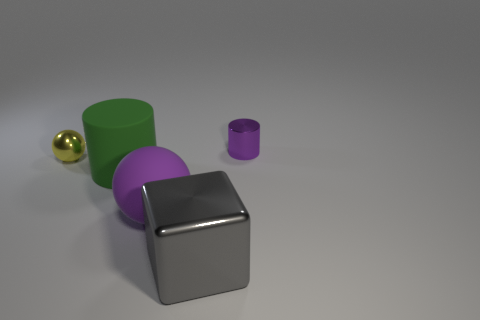What number of tiny metal cylinders have the same color as the matte ball?
Your response must be concise. 1. There is a object that is the same color as the large rubber ball; what size is it?
Your answer should be compact. Small. Is the material of the purple ball the same as the big cylinder?
Your answer should be very brief. Yes. There is a shiny object that is the same size as the green matte thing; what is its color?
Offer a terse response. Gray. How many other things are there of the same shape as the small purple metallic thing?
Make the answer very short. 1. There is a yellow object; does it have the same size as the purple object that is on the left side of the cube?
Provide a short and direct response. No. How many things are either large rubber spheres or small purple objects?
Your answer should be compact. 2. What number of other things are the same size as the yellow thing?
Your answer should be very brief. 1. There is a small sphere; is it the same color as the cylinder right of the large rubber ball?
Make the answer very short. No. What number of blocks are either big gray metallic things or purple metallic things?
Ensure brevity in your answer.  1. 